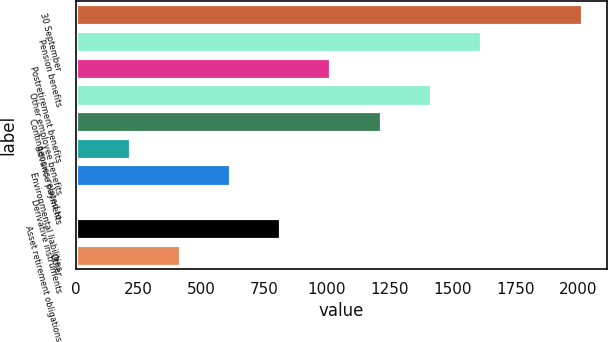Convert chart. <chart><loc_0><loc_0><loc_500><loc_500><bar_chart><fcel>30 September<fcel>Pension benefits<fcel>Postretirement benefits<fcel>Other employee benefits<fcel>Contingencies related to<fcel>Advance payments<fcel>Environmental liabilities<fcel>Derivative instruments<fcel>Asset retirement obligations<fcel>Other<nl><fcel>2013<fcel>1613.16<fcel>1013.4<fcel>1413.24<fcel>1213.32<fcel>213.72<fcel>613.56<fcel>13.8<fcel>813.48<fcel>413.64<nl></chart> 